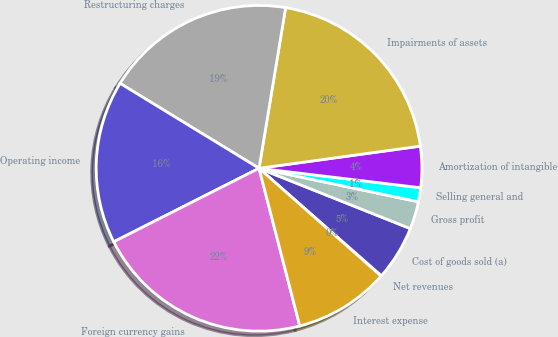<chart> <loc_0><loc_0><loc_500><loc_500><pie_chart><fcel>Net revenues<fcel>Cost of goods sold (a)<fcel>Gross profit<fcel>Selling general and<fcel>Amortization of intangible<fcel>Impairments of assets<fcel>Restructuring charges<fcel>Operating income<fcel>Foreign currency gains<fcel>Interest expense<nl><fcel>0.05%<fcel>5.43%<fcel>2.74%<fcel>1.39%<fcel>4.08%<fcel>20.22%<fcel>18.88%<fcel>16.19%<fcel>21.57%<fcel>9.46%<nl></chart> 